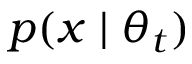<formula> <loc_0><loc_0><loc_500><loc_500>p ( x | \theta _ { t } )</formula> 